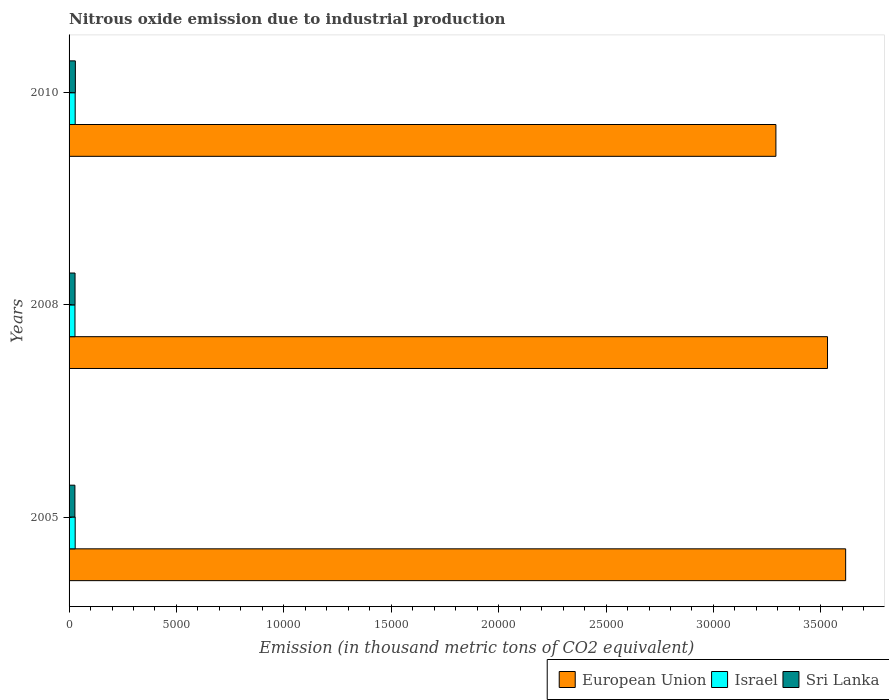Are the number of bars on each tick of the Y-axis equal?
Offer a very short reply. Yes. How many bars are there on the 3rd tick from the top?
Your response must be concise. 3. How many bars are there on the 3rd tick from the bottom?
Give a very brief answer. 3. In how many cases, is the number of bars for a given year not equal to the number of legend labels?
Keep it short and to the point. 0. What is the amount of nitrous oxide emitted in Sri Lanka in 2005?
Your answer should be compact. 271.8. Across all years, what is the maximum amount of nitrous oxide emitted in European Union?
Provide a short and direct response. 3.62e+04. Across all years, what is the minimum amount of nitrous oxide emitted in Israel?
Provide a short and direct response. 275.4. In which year was the amount of nitrous oxide emitted in European Union maximum?
Your response must be concise. 2005. What is the total amount of nitrous oxide emitted in Sri Lanka in the graph?
Offer a terse response. 842.5. What is the difference between the amount of nitrous oxide emitted in European Union in 2008 and that in 2010?
Your answer should be very brief. 2402.5. What is the difference between the amount of nitrous oxide emitted in Israel in 2010 and the amount of nitrous oxide emitted in Sri Lanka in 2008?
Make the answer very short. 6.7. What is the average amount of nitrous oxide emitted in European Union per year?
Your answer should be very brief. 3.48e+04. In the year 2010, what is the difference between the amount of nitrous oxide emitted in European Union and amount of nitrous oxide emitted in Sri Lanka?
Your response must be concise. 3.26e+04. What is the ratio of the amount of nitrous oxide emitted in Sri Lanka in 2005 to that in 2008?
Your answer should be compact. 0.98. Is the amount of nitrous oxide emitted in European Union in 2005 less than that in 2010?
Ensure brevity in your answer.  No. What is the difference between the highest and the second highest amount of nitrous oxide emitted in Israel?
Ensure brevity in your answer.  0.1. What is the difference between the highest and the lowest amount of nitrous oxide emitted in Israel?
Offer a very short reply. 9.6. In how many years, is the amount of nitrous oxide emitted in European Union greater than the average amount of nitrous oxide emitted in European Union taken over all years?
Offer a very short reply. 2. What does the 1st bar from the top in 2005 represents?
Provide a short and direct response. Sri Lanka. What does the 1st bar from the bottom in 2008 represents?
Give a very brief answer. European Union. How many years are there in the graph?
Your response must be concise. 3. What is the difference between two consecutive major ticks on the X-axis?
Your answer should be compact. 5000. Does the graph contain any zero values?
Offer a terse response. No. How many legend labels are there?
Provide a succinct answer. 3. How are the legend labels stacked?
Offer a terse response. Horizontal. What is the title of the graph?
Offer a very short reply. Nitrous oxide emission due to industrial production. Does "Lesotho" appear as one of the legend labels in the graph?
Provide a short and direct response. No. What is the label or title of the X-axis?
Ensure brevity in your answer.  Emission (in thousand metric tons of CO2 equivalent). What is the label or title of the Y-axis?
Your response must be concise. Years. What is the Emission (in thousand metric tons of CO2 equivalent) in European Union in 2005?
Give a very brief answer. 3.62e+04. What is the Emission (in thousand metric tons of CO2 equivalent) of Israel in 2005?
Your answer should be compact. 284.9. What is the Emission (in thousand metric tons of CO2 equivalent) of Sri Lanka in 2005?
Keep it short and to the point. 271.8. What is the Emission (in thousand metric tons of CO2 equivalent) of European Union in 2008?
Offer a terse response. 3.53e+04. What is the Emission (in thousand metric tons of CO2 equivalent) in Israel in 2008?
Provide a succinct answer. 275.4. What is the Emission (in thousand metric tons of CO2 equivalent) of Sri Lanka in 2008?
Your answer should be compact. 278.3. What is the Emission (in thousand metric tons of CO2 equivalent) in European Union in 2010?
Ensure brevity in your answer.  3.29e+04. What is the Emission (in thousand metric tons of CO2 equivalent) in Israel in 2010?
Your response must be concise. 285. What is the Emission (in thousand metric tons of CO2 equivalent) in Sri Lanka in 2010?
Your answer should be compact. 292.4. Across all years, what is the maximum Emission (in thousand metric tons of CO2 equivalent) of European Union?
Your response must be concise. 3.62e+04. Across all years, what is the maximum Emission (in thousand metric tons of CO2 equivalent) of Israel?
Offer a very short reply. 285. Across all years, what is the maximum Emission (in thousand metric tons of CO2 equivalent) in Sri Lanka?
Offer a very short reply. 292.4. Across all years, what is the minimum Emission (in thousand metric tons of CO2 equivalent) in European Union?
Your response must be concise. 3.29e+04. Across all years, what is the minimum Emission (in thousand metric tons of CO2 equivalent) of Israel?
Keep it short and to the point. 275.4. Across all years, what is the minimum Emission (in thousand metric tons of CO2 equivalent) in Sri Lanka?
Give a very brief answer. 271.8. What is the total Emission (in thousand metric tons of CO2 equivalent) in European Union in the graph?
Offer a very short reply. 1.04e+05. What is the total Emission (in thousand metric tons of CO2 equivalent) of Israel in the graph?
Your answer should be compact. 845.3. What is the total Emission (in thousand metric tons of CO2 equivalent) of Sri Lanka in the graph?
Your answer should be very brief. 842.5. What is the difference between the Emission (in thousand metric tons of CO2 equivalent) in European Union in 2005 and that in 2008?
Your answer should be compact. 845. What is the difference between the Emission (in thousand metric tons of CO2 equivalent) of Israel in 2005 and that in 2008?
Your response must be concise. 9.5. What is the difference between the Emission (in thousand metric tons of CO2 equivalent) of Sri Lanka in 2005 and that in 2008?
Provide a short and direct response. -6.5. What is the difference between the Emission (in thousand metric tons of CO2 equivalent) of European Union in 2005 and that in 2010?
Provide a succinct answer. 3247.5. What is the difference between the Emission (in thousand metric tons of CO2 equivalent) in Sri Lanka in 2005 and that in 2010?
Your answer should be very brief. -20.6. What is the difference between the Emission (in thousand metric tons of CO2 equivalent) of European Union in 2008 and that in 2010?
Keep it short and to the point. 2402.5. What is the difference between the Emission (in thousand metric tons of CO2 equivalent) of Israel in 2008 and that in 2010?
Your answer should be compact. -9.6. What is the difference between the Emission (in thousand metric tons of CO2 equivalent) in Sri Lanka in 2008 and that in 2010?
Keep it short and to the point. -14.1. What is the difference between the Emission (in thousand metric tons of CO2 equivalent) in European Union in 2005 and the Emission (in thousand metric tons of CO2 equivalent) in Israel in 2008?
Your answer should be compact. 3.59e+04. What is the difference between the Emission (in thousand metric tons of CO2 equivalent) of European Union in 2005 and the Emission (in thousand metric tons of CO2 equivalent) of Sri Lanka in 2008?
Ensure brevity in your answer.  3.59e+04. What is the difference between the Emission (in thousand metric tons of CO2 equivalent) of European Union in 2005 and the Emission (in thousand metric tons of CO2 equivalent) of Israel in 2010?
Offer a very short reply. 3.59e+04. What is the difference between the Emission (in thousand metric tons of CO2 equivalent) of European Union in 2005 and the Emission (in thousand metric tons of CO2 equivalent) of Sri Lanka in 2010?
Offer a very short reply. 3.59e+04. What is the difference between the Emission (in thousand metric tons of CO2 equivalent) in Israel in 2005 and the Emission (in thousand metric tons of CO2 equivalent) in Sri Lanka in 2010?
Give a very brief answer. -7.5. What is the difference between the Emission (in thousand metric tons of CO2 equivalent) of European Union in 2008 and the Emission (in thousand metric tons of CO2 equivalent) of Israel in 2010?
Provide a short and direct response. 3.50e+04. What is the difference between the Emission (in thousand metric tons of CO2 equivalent) in European Union in 2008 and the Emission (in thousand metric tons of CO2 equivalent) in Sri Lanka in 2010?
Ensure brevity in your answer.  3.50e+04. What is the difference between the Emission (in thousand metric tons of CO2 equivalent) in Israel in 2008 and the Emission (in thousand metric tons of CO2 equivalent) in Sri Lanka in 2010?
Your answer should be very brief. -17. What is the average Emission (in thousand metric tons of CO2 equivalent) of European Union per year?
Provide a short and direct response. 3.48e+04. What is the average Emission (in thousand metric tons of CO2 equivalent) in Israel per year?
Your answer should be compact. 281.77. What is the average Emission (in thousand metric tons of CO2 equivalent) in Sri Lanka per year?
Keep it short and to the point. 280.83. In the year 2005, what is the difference between the Emission (in thousand metric tons of CO2 equivalent) in European Union and Emission (in thousand metric tons of CO2 equivalent) in Israel?
Offer a terse response. 3.59e+04. In the year 2005, what is the difference between the Emission (in thousand metric tons of CO2 equivalent) of European Union and Emission (in thousand metric tons of CO2 equivalent) of Sri Lanka?
Offer a terse response. 3.59e+04. In the year 2005, what is the difference between the Emission (in thousand metric tons of CO2 equivalent) in Israel and Emission (in thousand metric tons of CO2 equivalent) in Sri Lanka?
Your response must be concise. 13.1. In the year 2008, what is the difference between the Emission (in thousand metric tons of CO2 equivalent) in European Union and Emission (in thousand metric tons of CO2 equivalent) in Israel?
Offer a very short reply. 3.50e+04. In the year 2008, what is the difference between the Emission (in thousand metric tons of CO2 equivalent) in European Union and Emission (in thousand metric tons of CO2 equivalent) in Sri Lanka?
Provide a short and direct response. 3.50e+04. In the year 2010, what is the difference between the Emission (in thousand metric tons of CO2 equivalent) of European Union and Emission (in thousand metric tons of CO2 equivalent) of Israel?
Give a very brief answer. 3.26e+04. In the year 2010, what is the difference between the Emission (in thousand metric tons of CO2 equivalent) of European Union and Emission (in thousand metric tons of CO2 equivalent) of Sri Lanka?
Provide a succinct answer. 3.26e+04. In the year 2010, what is the difference between the Emission (in thousand metric tons of CO2 equivalent) of Israel and Emission (in thousand metric tons of CO2 equivalent) of Sri Lanka?
Your response must be concise. -7.4. What is the ratio of the Emission (in thousand metric tons of CO2 equivalent) in European Union in 2005 to that in 2008?
Ensure brevity in your answer.  1.02. What is the ratio of the Emission (in thousand metric tons of CO2 equivalent) in Israel in 2005 to that in 2008?
Your answer should be very brief. 1.03. What is the ratio of the Emission (in thousand metric tons of CO2 equivalent) in Sri Lanka in 2005 to that in 2008?
Provide a short and direct response. 0.98. What is the ratio of the Emission (in thousand metric tons of CO2 equivalent) of European Union in 2005 to that in 2010?
Provide a short and direct response. 1.1. What is the ratio of the Emission (in thousand metric tons of CO2 equivalent) in Israel in 2005 to that in 2010?
Give a very brief answer. 1. What is the ratio of the Emission (in thousand metric tons of CO2 equivalent) of Sri Lanka in 2005 to that in 2010?
Provide a succinct answer. 0.93. What is the ratio of the Emission (in thousand metric tons of CO2 equivalent) in European Union in 2008 to that in 2010?
Offer a terse response. 1.07. What is the ratio of the Emission (in thousand metric tons of CO2 equivalent) in Israel in 2008 to that in 2010?
Give a very brief answer. 0.97. What is the ratio of the Emission (in thousand metric tons of CO2 equivalent) of Sri Lanka in 2008 to that in 2010?
Ensure brevity in your answer.  0.95. What is the difference between the highest and the second highest Emission (in thousand metric tons of CO2 equivalent) of European Union?
Your answer should be compact. 845. What is the difference between the highest and the second highest Emission (in thousand metric tons of CO2 equivalent) in Israel?
Make the answer very short. 0.1. What is the difference between the highest and the lowest Emission (in thousand metric tons of CO2 equivalent) in European Union?
Your answer should be very brief. 3247.5. What is the difference between the highest and the lowest Emission (in thousand metric tons of CO2 equivalent) of Sri Lanka?
Provide a short and direct response. 20.6. 